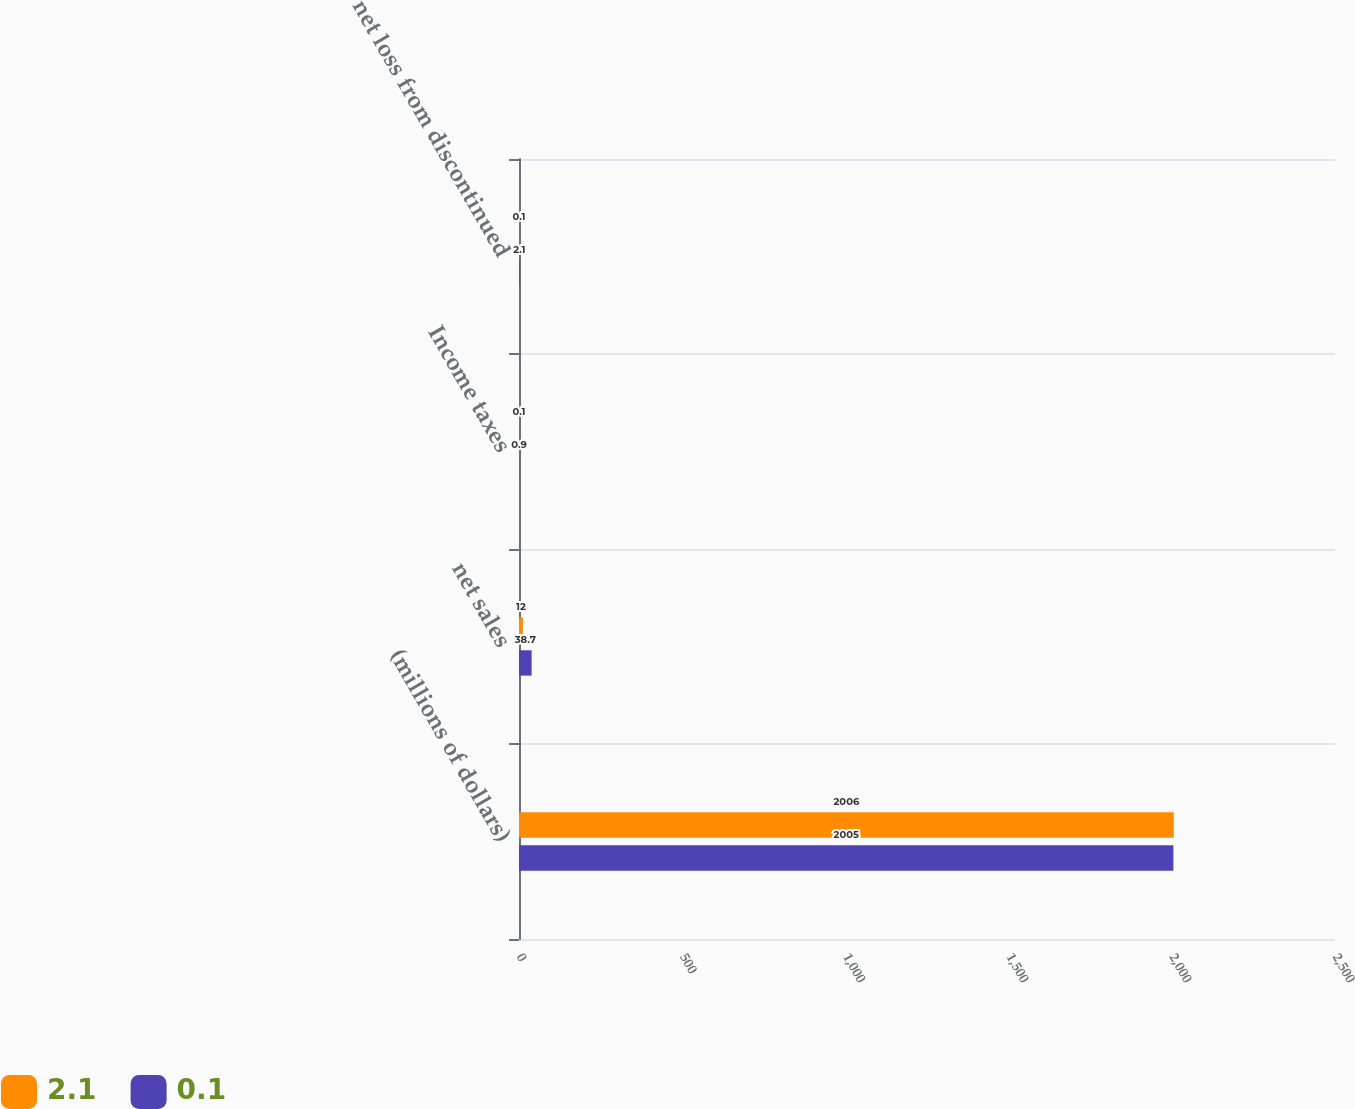<chart> <loc_0><loc_0><loc_500><loc_500><stacked_bar_chart><ecel><fcel>(millions of dollars)<fcel>net sales<fcel>Income taxes<fcel>net loss from discontinued<nl><fcel>2.1<fcel>2006<fcel>12<fcel>0.1<fcel>0.1<nl><fcel>0.1<fcel>2005<fcel>38.7<fcel>0.9<fcel>2.1<nl></chart> 